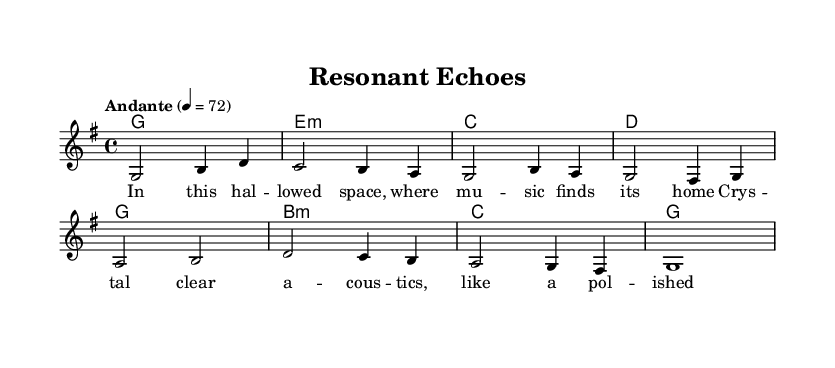What is the key signature of this music? The key signature is indicated at the beginning of the score. In this case, there is one sharp, which signifies G major or E minor. As G major is the predominant key used throughout the piece, we conclude that the key signature is G major.
Answer: G major What is the time signature of this music? The time signature is found at the beginning of the score, indicated as 4/4. This means there are four beats in each measure, and a quarter note gets one beat.
Answer: 4/4 What is the tempo marking? The tempo marking appears as "Andante" and is notated with a metronome marking of 4 = 72. "Andante" suggests a moderate pace. This means each quarter note should be played at a speed of 72 beats per minute.
Answer: Andante How many measures are present in the melody? To determine the number of measures, we count the vertical bars which indicate the beginning and end of each measure. There are a total of eight measures in the melody indicated by the vertical lines.
Answer: Eight Which chord is played in the first measure? The first measure of the score displays a chord symbol above the melody, which indicates a G major chord. This styling demonstrates that a G major chord is played in the accompaniment.
Answer: G major How many lines are in the lyrics section? The lyrics are presented beneath the melody and are structured in two lines. By visually examining the lyrics, we can see it forms a couplet.
Answer: Two What is the emotional theme reflected in the lyrics? The lyrics convey a feeling of reverence and beauty for the concert hall and its acoustics. Words like "hal -- lowed space" and "crys -- tal clear a -- cous -- tics" indicate appreciation for the environment.
Answer: Reverence 